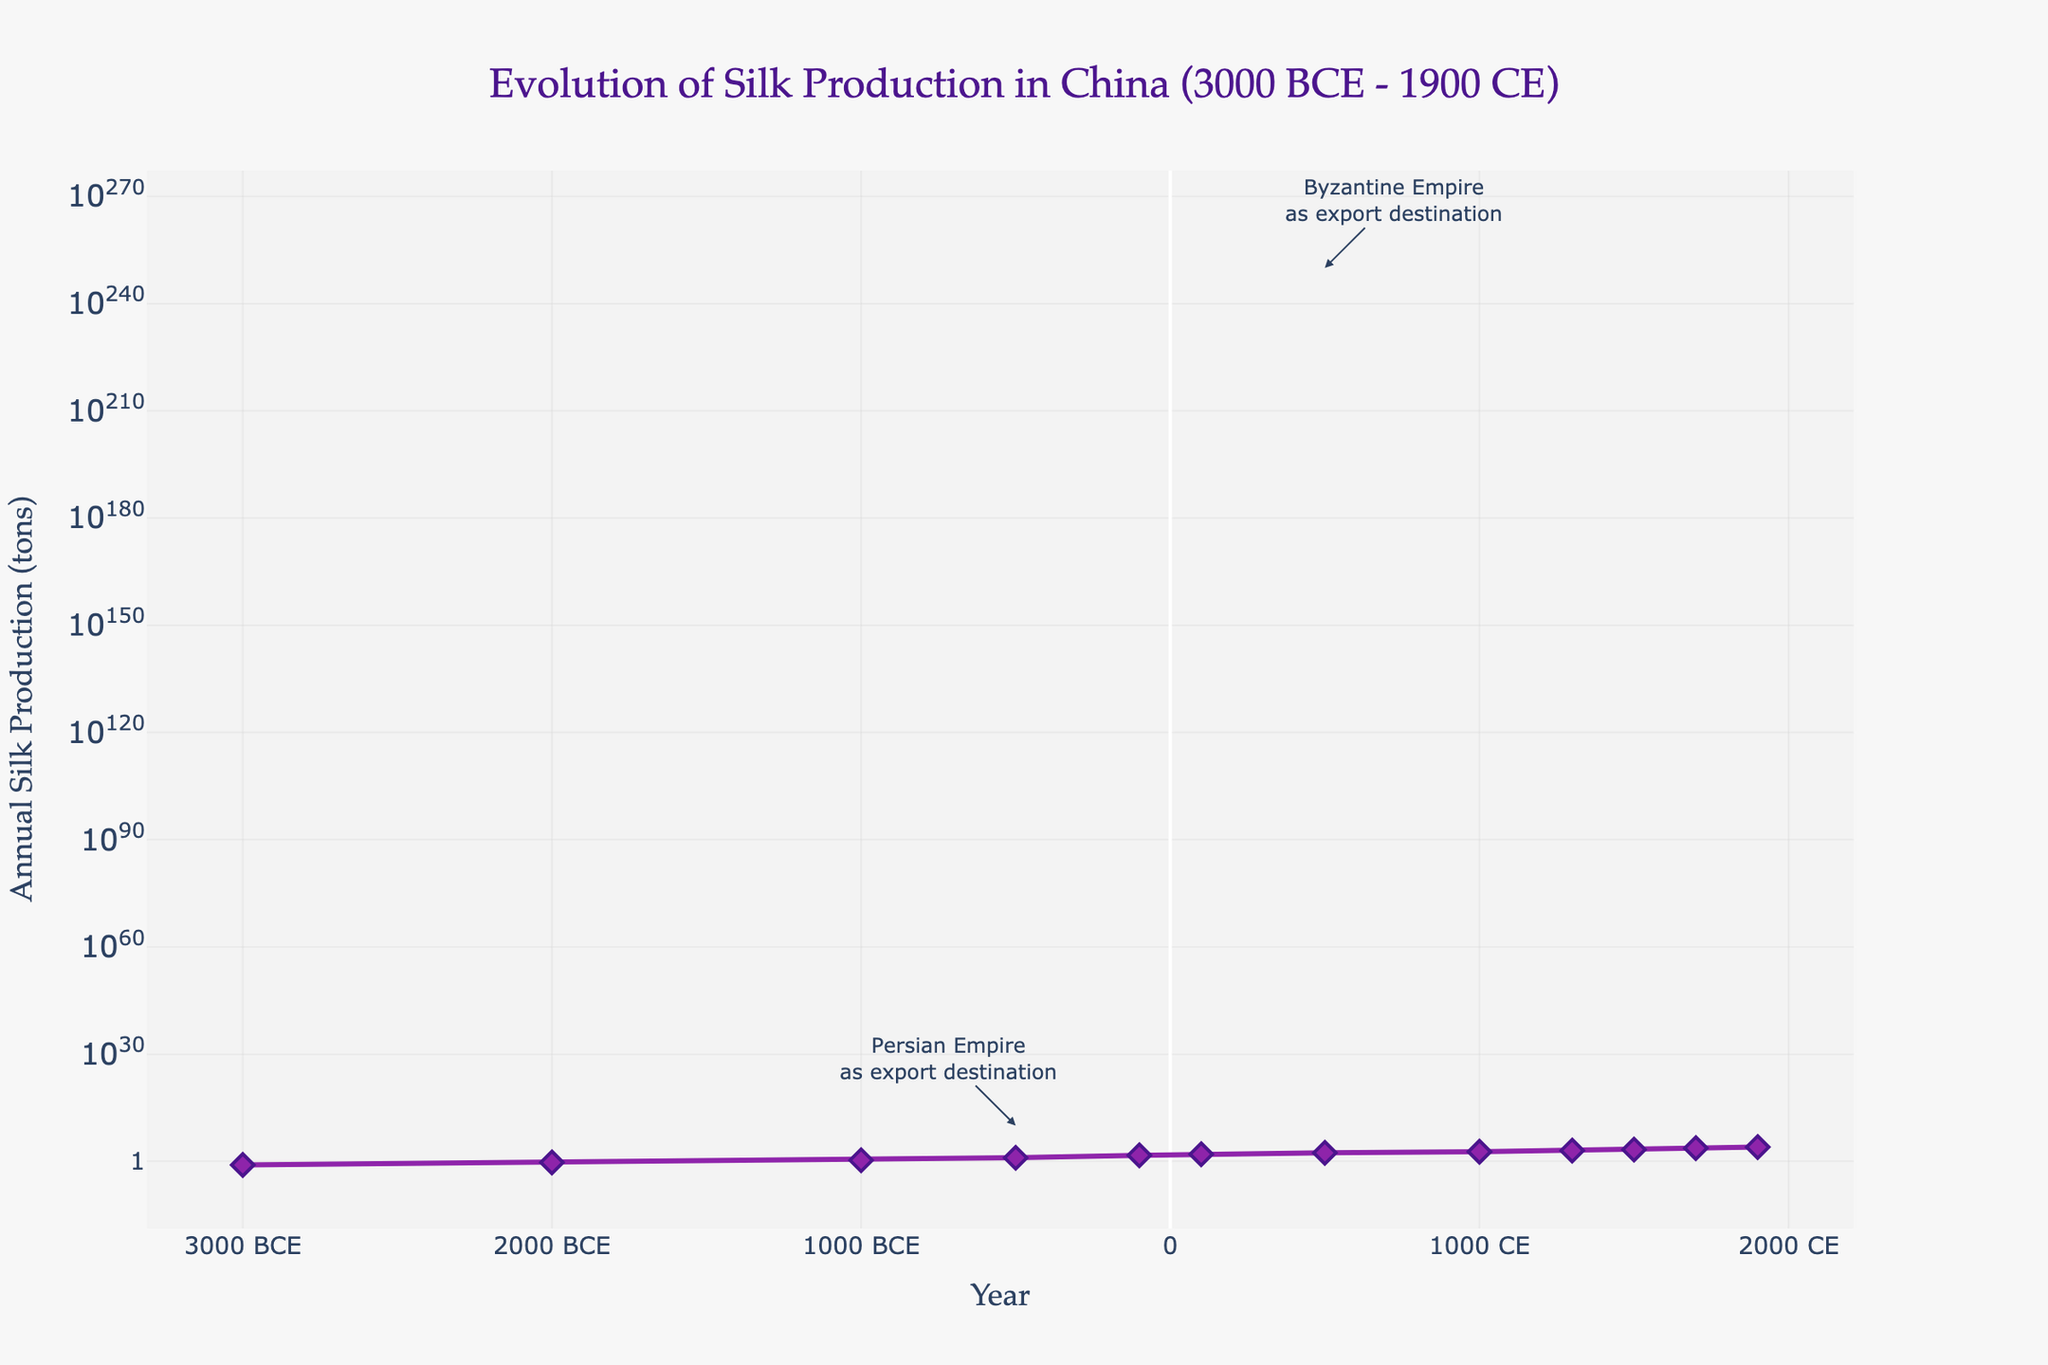When did silk production first exceed 1000 tons, and what was the primary export destination at that time? Silk production first exceeded 1000 tons around 1300 CE. At that time, the primary export destination was the Mongol Empire.
Answer: 1300 CE, Mongol Empire By how much did silk production increase from 500 BCE to 100 BCE? Silk production increased from 10 tons in 500 BCE to 50 tons in 100 BCE. The difference is 50 tons - 10 tons = 40 tons.
Answer: 40 tons Which time period saw the largest increase in silk production, and what was the increment? The period from 1700 CE to 1900 CE saw the largest increase in silk production, from 5000 tons to 10000 tons, an increase of 5000 tons.
Answer: 1700 CE to 1900 CE, 5000 tons How does the silk production in 1000 CE compare to that in 1000 BCE? Silk production in 1000 CE was 500 tons, while in 1000 BCE it was 2 tons. Comparing the two, 500 tons is significantly higher than 2 tons.
Answer: 500 tons is significantly higher than 2 tons What period marks the transition from local use only to having international export destinations? The transition occurred between 2000 BCE and 1000 BCE. In 3000 BCE and 2000 BCE, the primary export destinations were local or neighboring tribes. By 1000 BCE, the export destinations included Central Asian kingdoms, indicating an international reach.
Answer: Between 2000 BCE and 1000 BCE Why might the annotations at -500, 500, and 1700 be significant? The annotations indicate major shifts in export destinations to the Persian Empire (~-500), Byzantine Empire (~500), and Western Europe (~1700), highlighting significant historical trade connections that likely influenced increased silk production.
Answer: Major historical trade connections What was the annual silk production around the time China started exporting to the Roman Empire? Around 100 BCE when China started exporting to the Roman Empire, the annual silk production was 50 tons.
Answer: 50 tons Can you name the regions of primary silk production and match them with two different centuries, e.g., 1000 BCE and 100 CE? In 1000 BCE, the primary production region was the Sichuan Basin. In 100 CE, the primary production region was Shaanxi Province.
Answer: Sichuan Basin (1000 BCE), Shaanxi Province (100 CE) How did the silk production change from 500 CE to 1000 CE, and what was the average annual growth in production over these years? Silk production increased from 250 tons in 500 CE to 500 tons in 1000 CE. The total increase is 500 - 250 = 250 tons over 500 years. The average annual growth is 250 tons / 500 years = 0.5 tons per year.
Answer: Increased by 250 tons, average annual growth 0.5 tons per year What does the log scale for the y-axis imply about the growth pattern of silk production? The log scale on the y-axis suggests exponential growth in silk production over time rather than linear. Smaller increments in earlier years show as equal vertical distances to larger increments in later years, indicating rapid growth in the latter periods.
Answer: Exponential growth pattern 